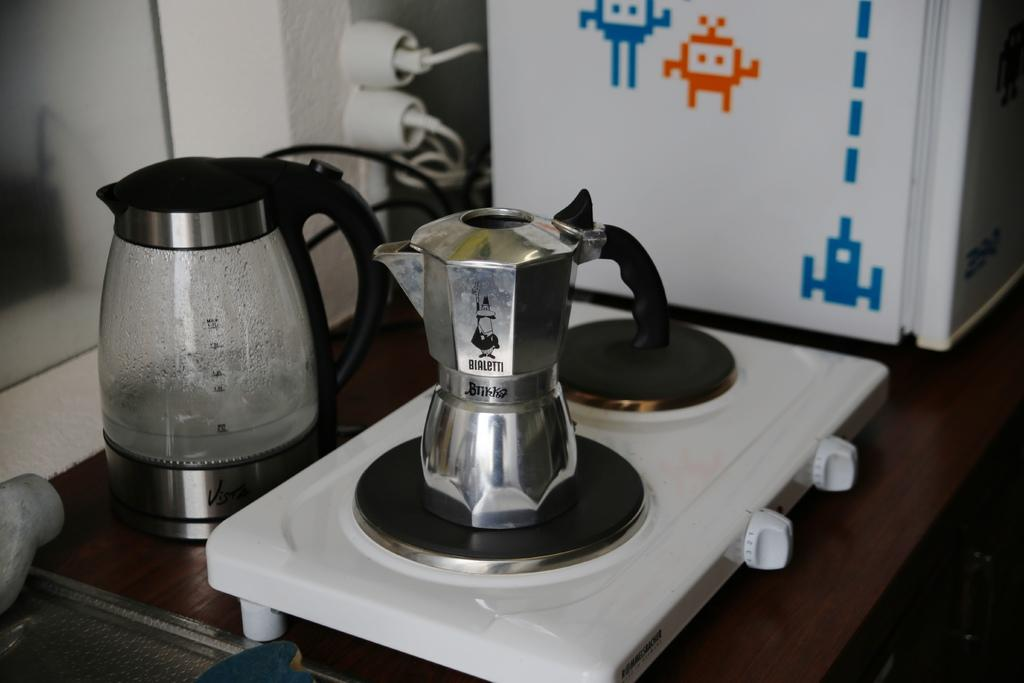<image>
Relay a brief, clear account of the picture shown. A coffee pot branded with BIALETTI printed on the surface sitting on a stove burner. 